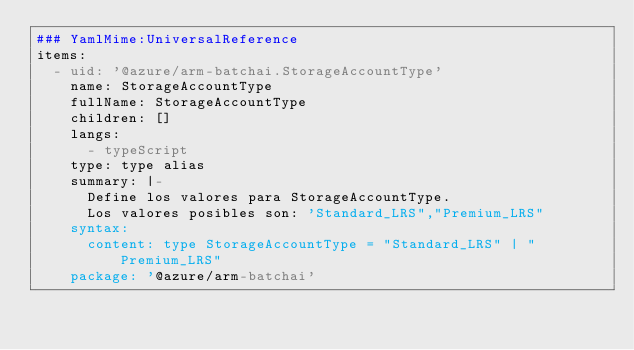Convert code to text. <code><loc_0><loc_0><loc_500><loc_500><_YAML_>### YamlMime:UniversalReference
items:
  - uid: '@azure/arm-batchai.StorageAccountType'
    name: StorageAccountType
    fullName: StorageAccountType
    children: []
    langs:
      - typeScript
    type: type alias
    summary: |-
      Define los valores para StorageAccountType.
      Los valores posibles son: 'Standard_LRS","Premium_LRS"
    syntax:
      content: type StorageAccountType = "Standard_LRS" | "Premium_LRS"
    package: '@azure/arm-batchai'</code> 